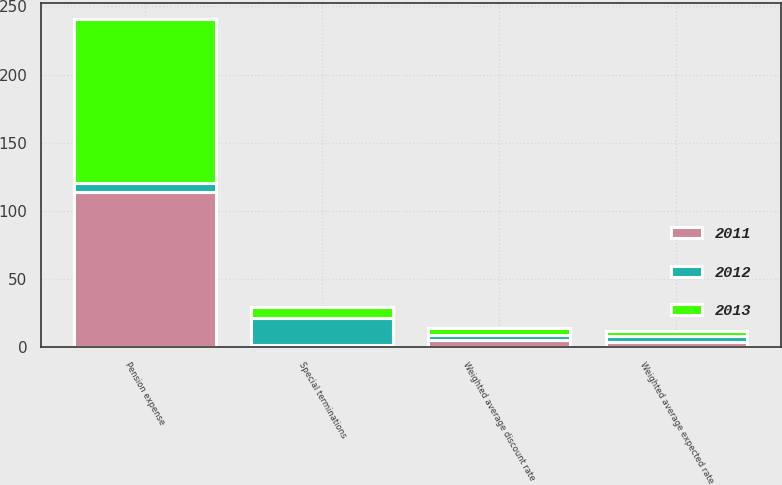Convert chart. <chart><loc_0><loc_0><loc_500><loc_500><stacked_bar_chart><ecel><fcel>Pension expense<fcel>Special terminations<fcel>Weighted average discount rate<fcel>Weighted average expected rate<nl><fcel>2012<fcel>6.35<fcel>19.8<fcel>4<fcel>3.8<nl><fcel>2013<fcel>120.4<fcel>8.2<fcel>5<fcel>3.9<nl><fcel>2011<fcel>114.1<fcel>1.3<fcel>5<fcel>4<nl></chart> 